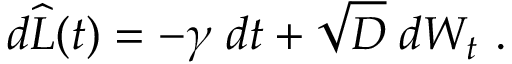Convert formula to latex. <formula><loc_0><loc_0><loc_500><loc_500>d \widehat { L } ( t ) = - \gamma \, d t + \sqrt { D } \, d W _ { t } \ .</formula> 